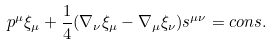<formula> <loc_0><loc_0><loc_500><loc_500>p ^ { \mu } \xi _ { \mu } + \frac { 1 } { 4 } ( \nabla _ { \nu } \xi _ { \mu } - \nabla _ { \mu } \xi _ { \nu } ) s ^ { \mu \nu } = c o n s .</formula> 